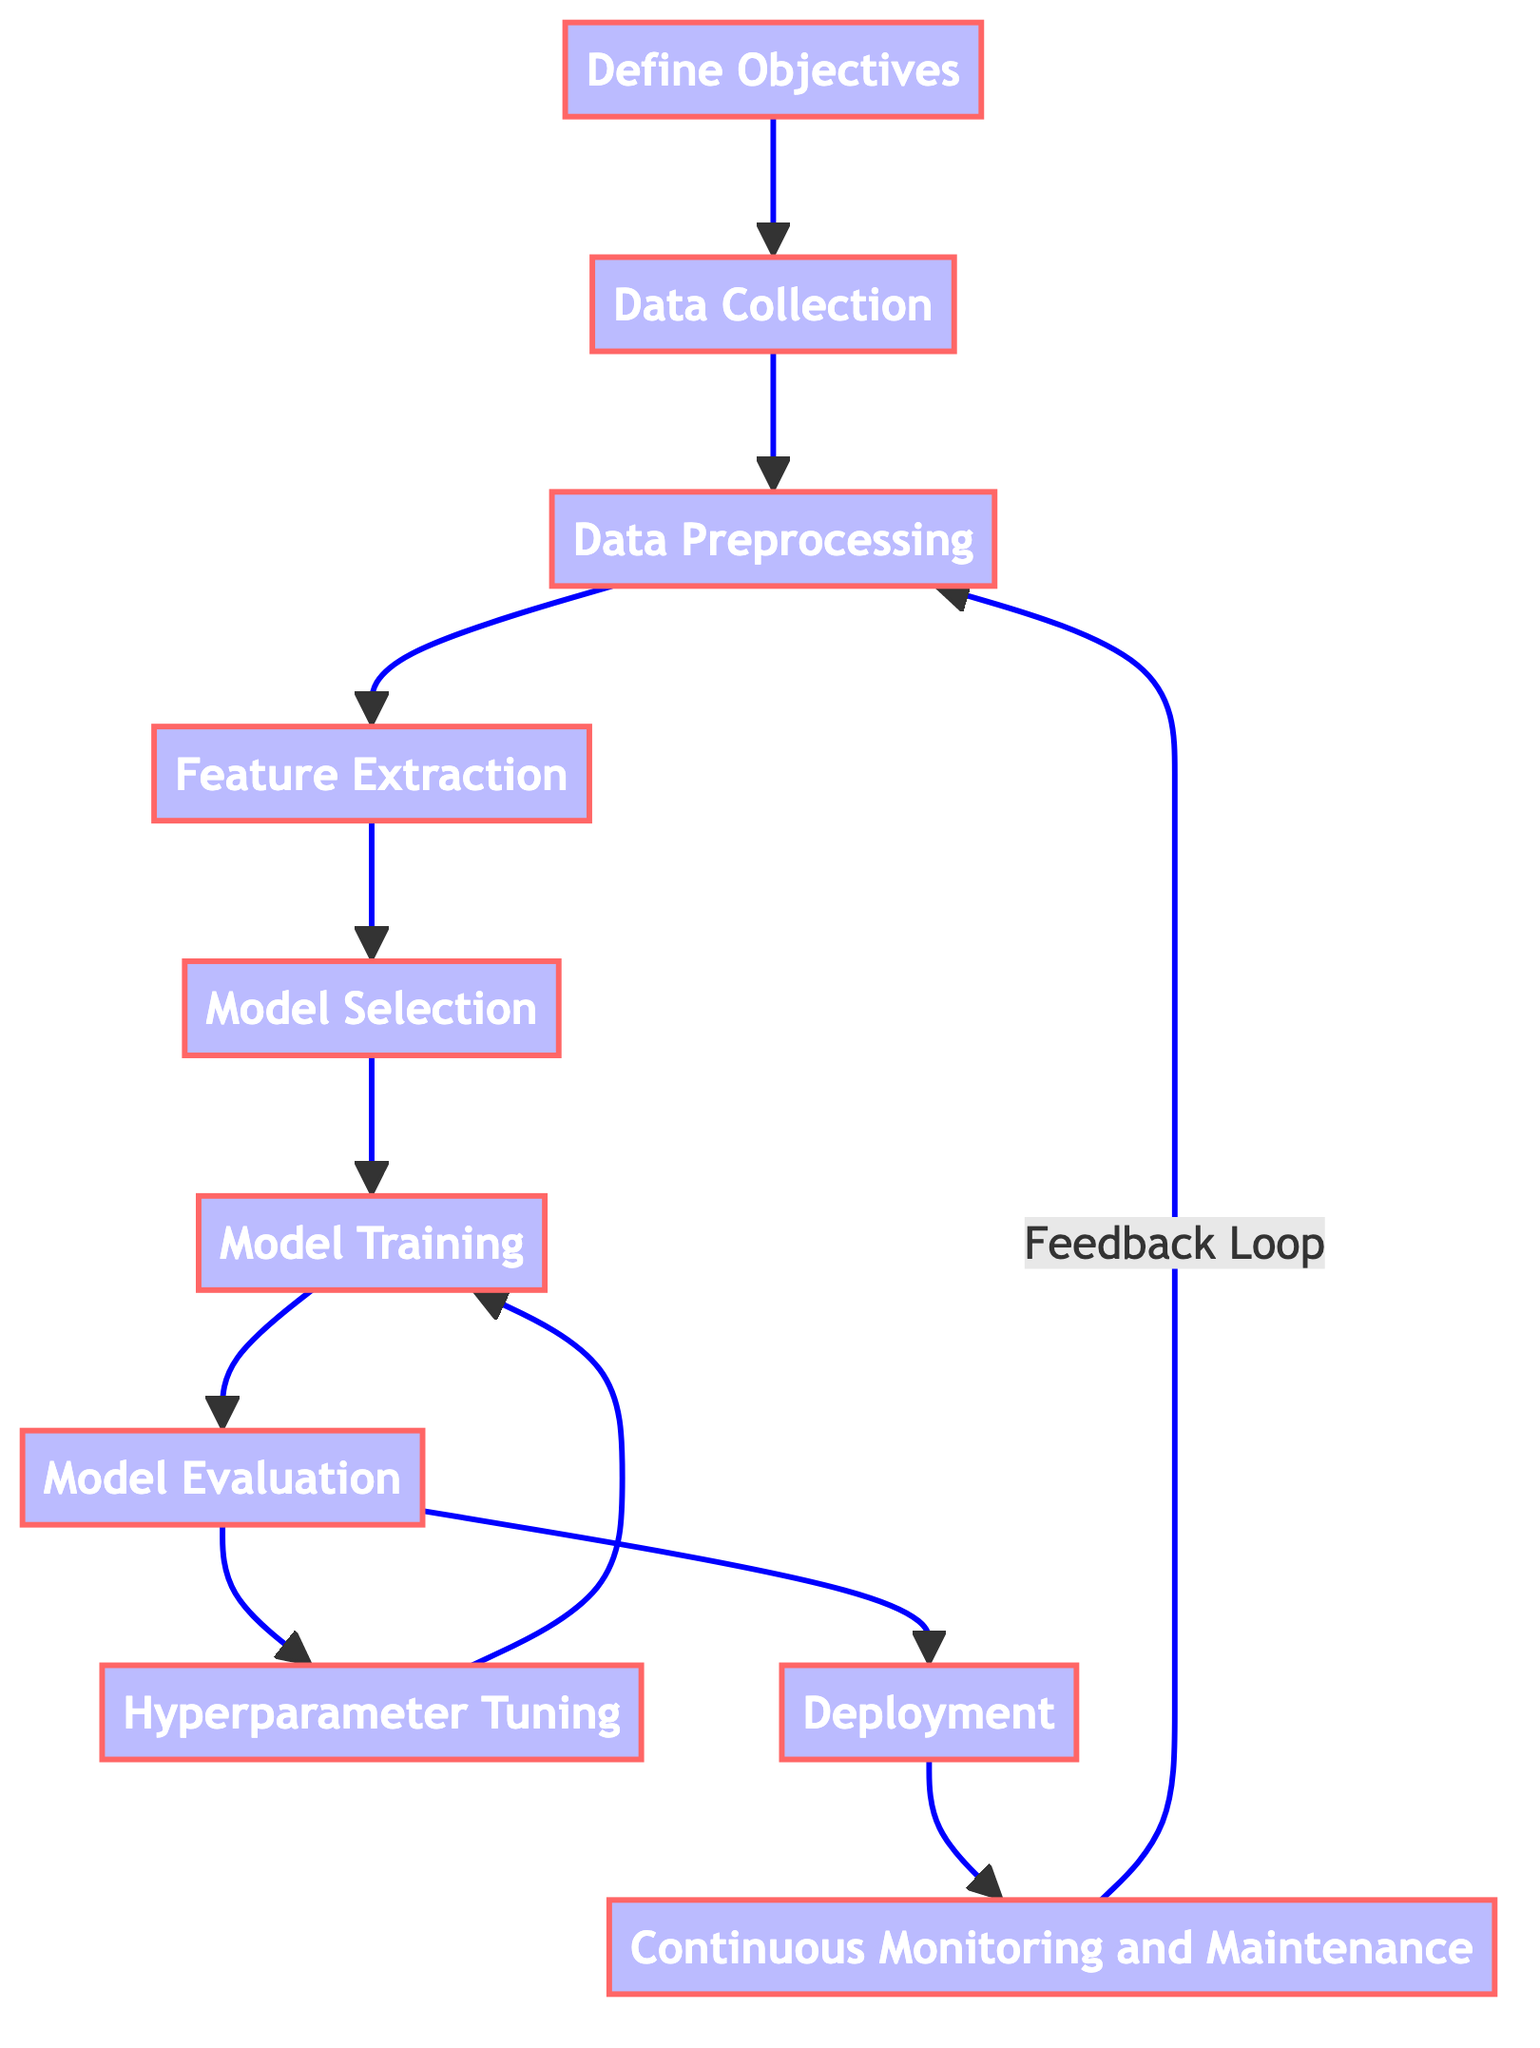What is the first step in the flow chart? The first step in the flow chart is "Define Objectives," which is the initial point of the process, indicating that the goals need to be identified before any other actions are taken.
Answer: Define Objectives How many steps are shown in the flow chart? The flow chart contains a total of ten steps, representing each major stage in developing a machine learning algorithm for galaxy classification.
Answer: Ten Which step follows "Data Preprocessing"? "Feature Extraction" follows "Data Preprocessing" in the flow chart. This sequence indicates that after cleaning and preparing the data, the next action is to extract relevant features from it.
Answer: Feature Extraction After "Model Evaluation," which step comes next? After "Model Evaluation," the next step is "Deployment." This indicates that once the model's performance is assessed, it can be deployed for classifying new galaxy data.
Answer: Deployment What are the two steps that follow "Model Training"? The two steps following "Model Training" are "Model Evaluation" and "Hyperparameter Tuning." This shows that after training the model, it undergoes evaluation, and there's also the opportunity for tuning the hyperparameters of the model.
Answer: Model Evaluation and Hyperparameter Tuning Is there a feedback loop in the flow chart? If so, where does it lead? Yes, there is a feedback loop in the flow chart, and it leads from "Continuous Monitoring and Maintenance" back to "Data Preprocessing." This indicates that based on monitoring performance, the data may need to be re-preprocessed to improve the model.
Answer: Yes, to Data Preprocessing Which two steps are directly connected to "Model Evaluation"? "Model Training" and "Deployment" are the two steps directly connected to "Model Evaluation." This means that evaluation leads to subsequent actions based on its results, either enhancing the model (through additional training) or deploying it for use.
Answer: Model Training and Deployment What step involves optimization for better performance? The step involving optimization for better performance is "Hyperparameter Tuning." This is where techniques are applied to adjust the parameters of the model to improve accuracy and effectiveness.
Answer: Hyperparameter Tuning In how many steps does the flow chart indicate a repetitive cycle? The flow chart indicates one repetitive cycle involving the steps "Model Training" and "Hyperparameter Tuning," suggesting that after evaluating the model, further training and tuning may be necessary to enhance performance.
Answer: One 